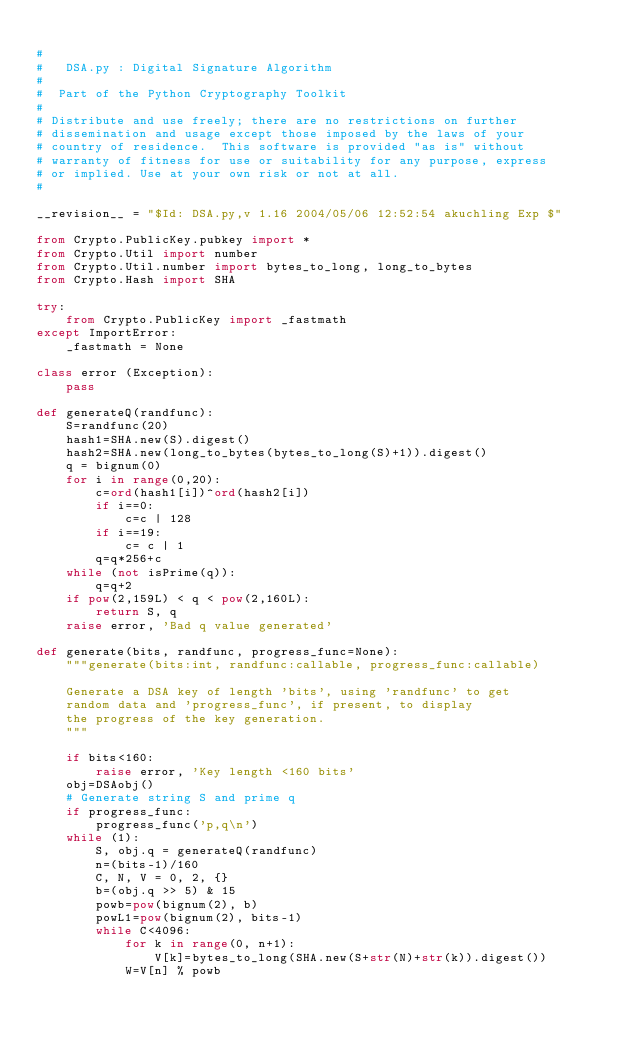<code> <loc_0><loc_0><loc_500><loc_500><_Python_>
#
#   DSA.py : Digital Signature Algorithm
#
#  Part of the Python Cryptography Toolkit
#
# Distribute and use freely; there are no restrictions on further
# dissemination and usage except those imposed by the laws of your
# country of residence.  This software is provided "as is" without
# warranty of fitness for use or suitability for any purpose, express
# or implied. Use at your own risk or not at all.
#

__revision__ = "$Id: DSA.py,v 1.16 2004/05/06 12:52:54 akuchling Exp $"

from Crypto.PublicKey.pubkey import *
from Crypto.Util import number
from Crypto.Util.number import bytes_to_long, long_to_bytes
from Crypto.Hash import SHA

try:
    from Crypto.PublicKey import _fastmath
except ImportError:
    _fastmath = None

class error (Exception):
    pass

def generateQ(randfunc):
    S=randfunc(20)
    hash1=SHA.new(S).digest()
    hash2=SHA.new(long_to_bytes(bytes_to_long(S)+1)).digest()
    q = bignum(0)
    for i in range(0,20):
        c=ord(hash1[i])^ord(hash2[i])
        if i==0:
            c=c | 128
        if i==19:
            c= c | 1
        q=q*256+c
    while (not isPrime(q)):
        q=q+2
    if pow(2,159L) < q < pow(2,160L):
        return S, q
    raise error, 'Bad q value generated'

def generate(bits, randfunc, progress_func=None):
    """generate(bits:int, randfunc:callable, progress_func:callable)

    Generate a DSA key of length 'bits', using 'randfunc' to get
    random data and 'progress_func', if present, to display
    the progress of the key generation.
    """

    if bits<160:
        raise error, 'Key length <160 bits'
    obj=DSAobj()
    # Generate string S and prime q
    if progress_func:
        progress_func('p,q\n')
    while (1):
        S, obj.q = generateQ(randfunc)
        n=(bits-1)/160
        C, N, V = 0, 2, {}
        b=(obj.q >> 5) & 15
        powb=pow(bignum(2), b)
        powL1=pow(bignum(2), bits-1)
        while C<4096:
            for k in range(0, n+1):
                V[k]=bytes_to_long(SHA.new(S+str(N)+str(k)).digest())
            W=V[n] % powb</code> 